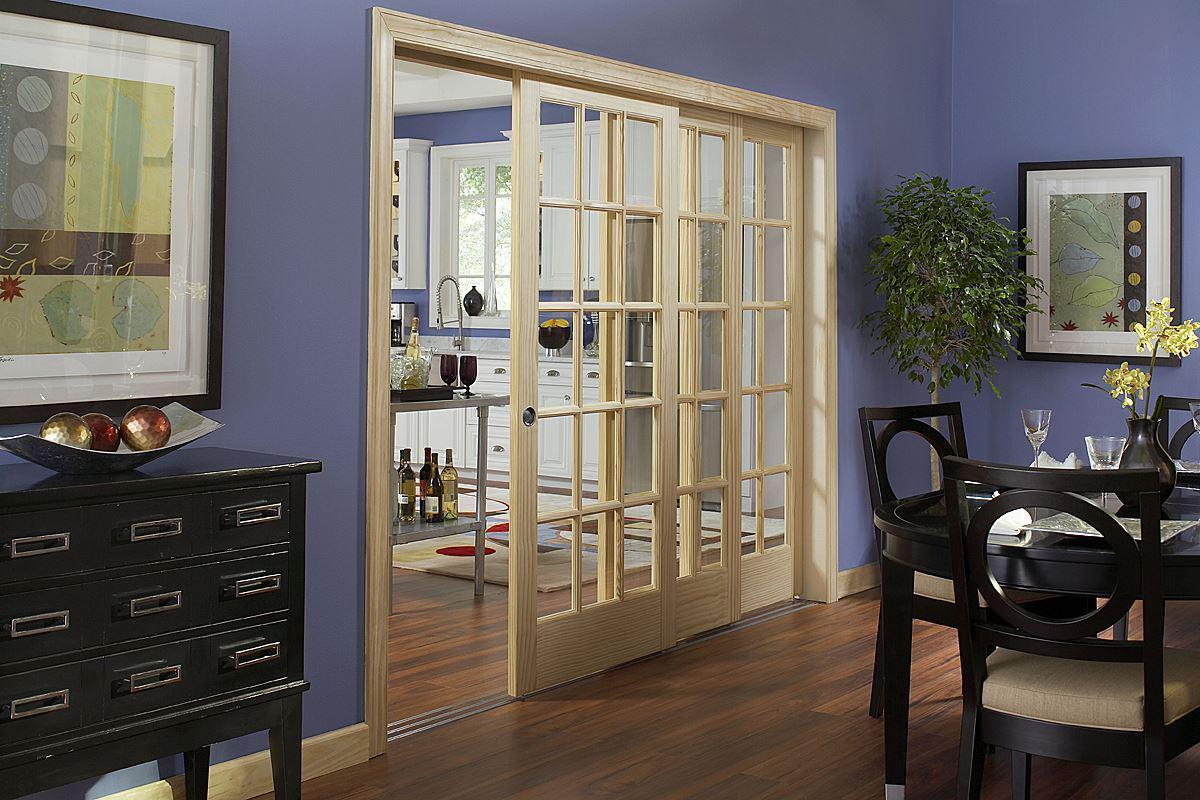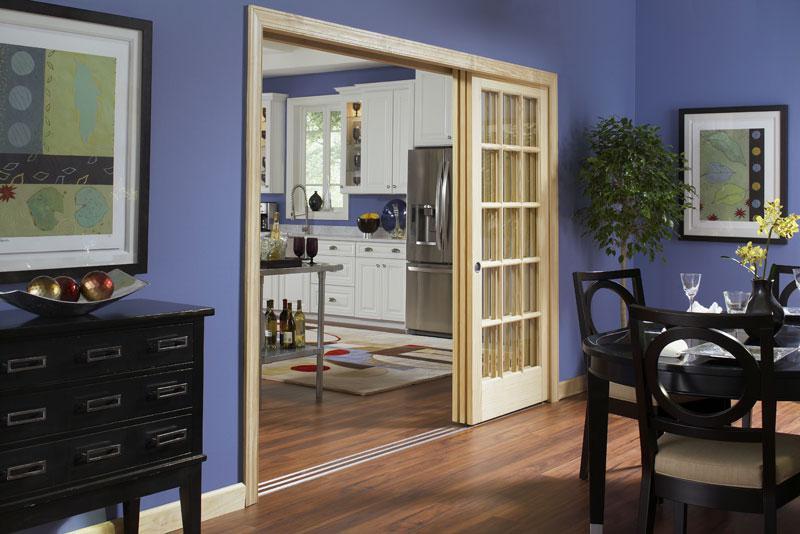The first image is the image on the left, the second image is the image on the right. Evaluate the accuracy of this statement regarding the images: "A set of doors opens to a dark colored table in the image ont he left.". Is it true? Answer yes or no. Yes. 